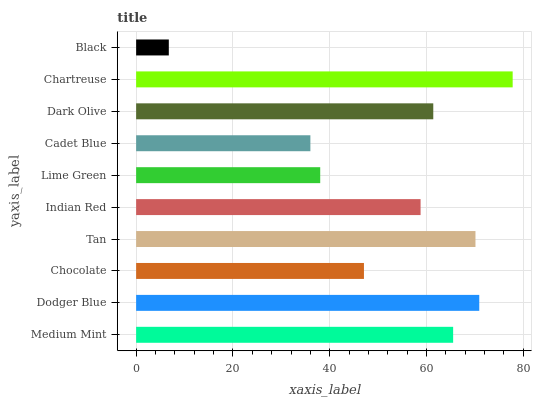Is Black the minimum?
Answer yes or no. Yes. Is Chartreuse the maximum?
Answer yes or no. Yes. Is Dodger Blue the minimum?
Answer yes or no. No. Is Dodger Blue the maximum?
Answer yes or no. No. Is Dodger Blue greater than Medium Mint?
Answer yes or no. Yes. Is Medium Mint less than Dodger Blue?
Answer yes or no. Yes. Is Medium Mint greater than Dodger Blue?
Answer yes or no. No. Is Dodger Blue less than Medium Mint?
Answer yes or no. No. Is Dark Olive the high median?
Answer yes or no. Yes. Is Indian Red the low median?
Answer yes or no. Yes. Is Black the high median?
Answer yes or no. No. Is Chocolate the low median?
Answer yes or no. No. 